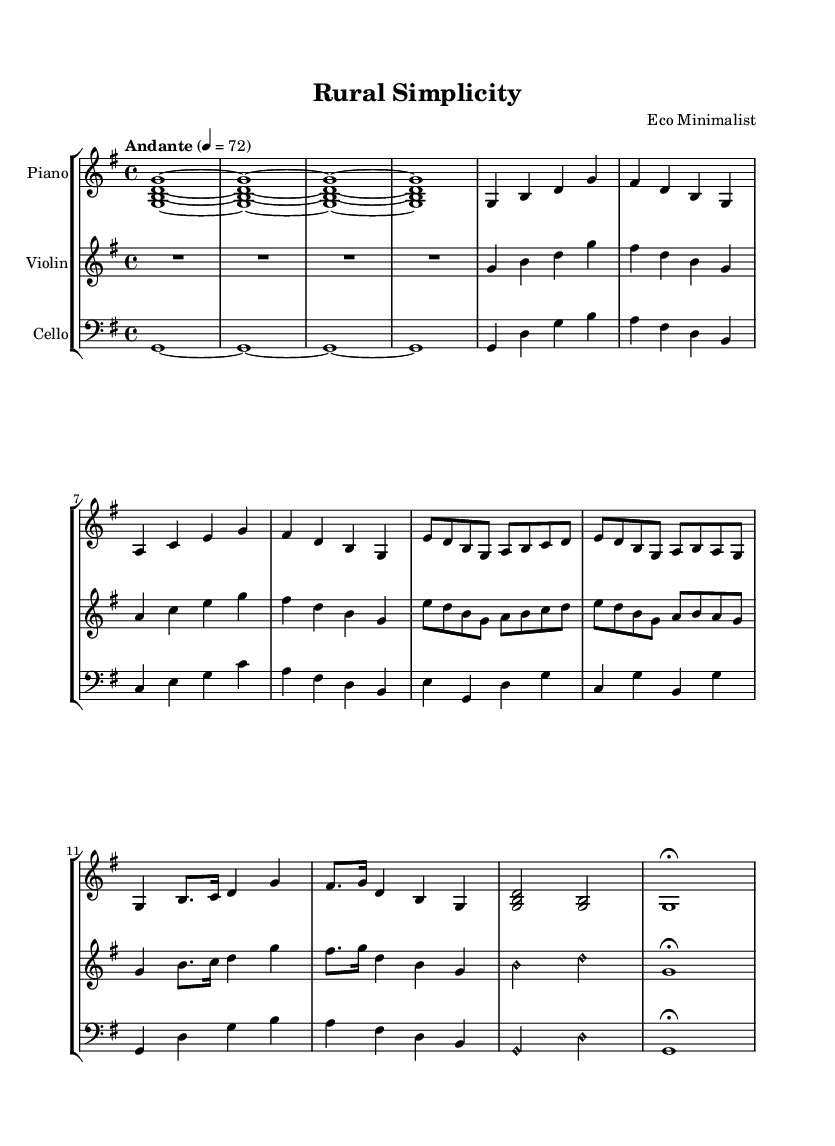What is the key signature of this music? The key signature shown is one sharp (F#), which indicates that the piece is in G major.
Answer: G major What is the time signature of this music? The time signature is indicated as a 4/4, which means there are four beats in each measure and the quarter note gets one beat.
Answer: 4/4 What is the tempo marking of this piece? The tempo marking states "Andante," which suggests a moderately slow tempo, usually around 76-108 beats per minute.
Answer: Andante How many measures are in the introduction section? The introduction consists of four measures, as indicated by the repeated section of the music that leads to the first theme.
Answer: 4 Which instruments are part of this score? The score includes a piano, a violin, and a cello, as indicated by the labels on each staff for the respective instruments.
Answer: Piano, Violin, Cello What is the name of the composer? The music sheet states that the composer is "Eco Minimalist," which reflects a style that emphasizes simplicity and environmental themes.
Answer: Eco Minimalist What is the structure of the piece based on the themes? The structure includes an introduction, two themes (A and B) with variations, and a coda, following a recognizable format for classical compositions.
Answer: Introduction, Theme A, Theme B, Variation, Coda 